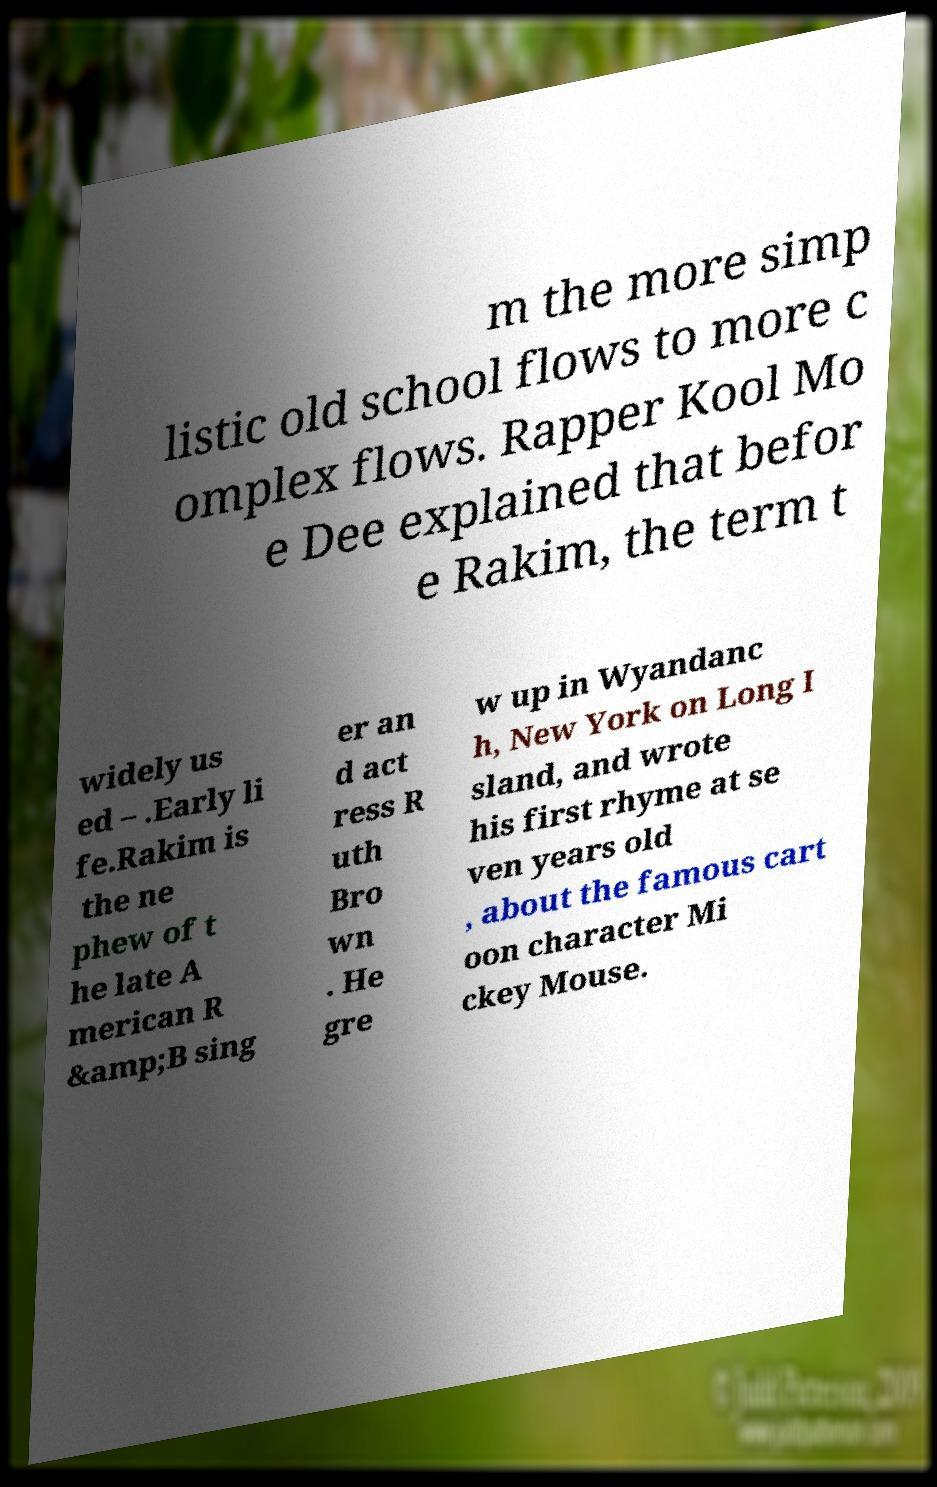Can you accurately transcribe the text from the provided image for me? m the more simp listic old school flows to more c omplex flows. Rapper Kool Mo e Dee explained that befor e Rakim, the term t widely us ed – .Early li fe.Rakim is the ne phew of t he late A merican R &amp;B sing er an d act ress R uth Bro wn . He gre w up in Wyandanc h, New York on Long I sland, and wrote his first rhyme at se ven years old , about the famous cart oon character Mi ckey Mouse. 